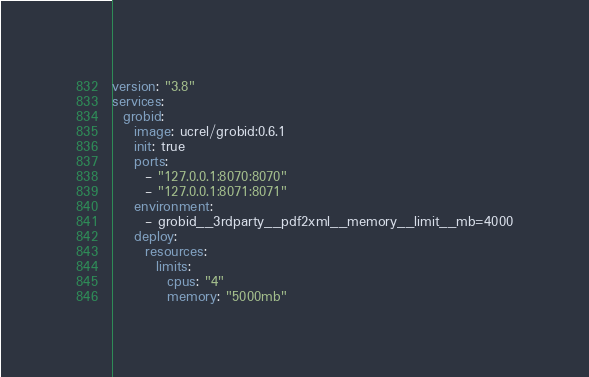Convert code to text. <code><loc_0><loc_0><loc_500><loc_500><_YAML_>version: "3.8"
services:
  grobid:
    image: ucrel/grobid:0.6.1
    init: true
    ports:
      - "127.0.0.1:8070:8070"
      - "127.0.0.1:8071:8071"
    environment:
      - grobid__3rdparty__pdf2xml__memory__limit__mb=4000
    deploy:
      resources:
        limits:
          cpus: "4"
          memory: "5000mb"</code> 